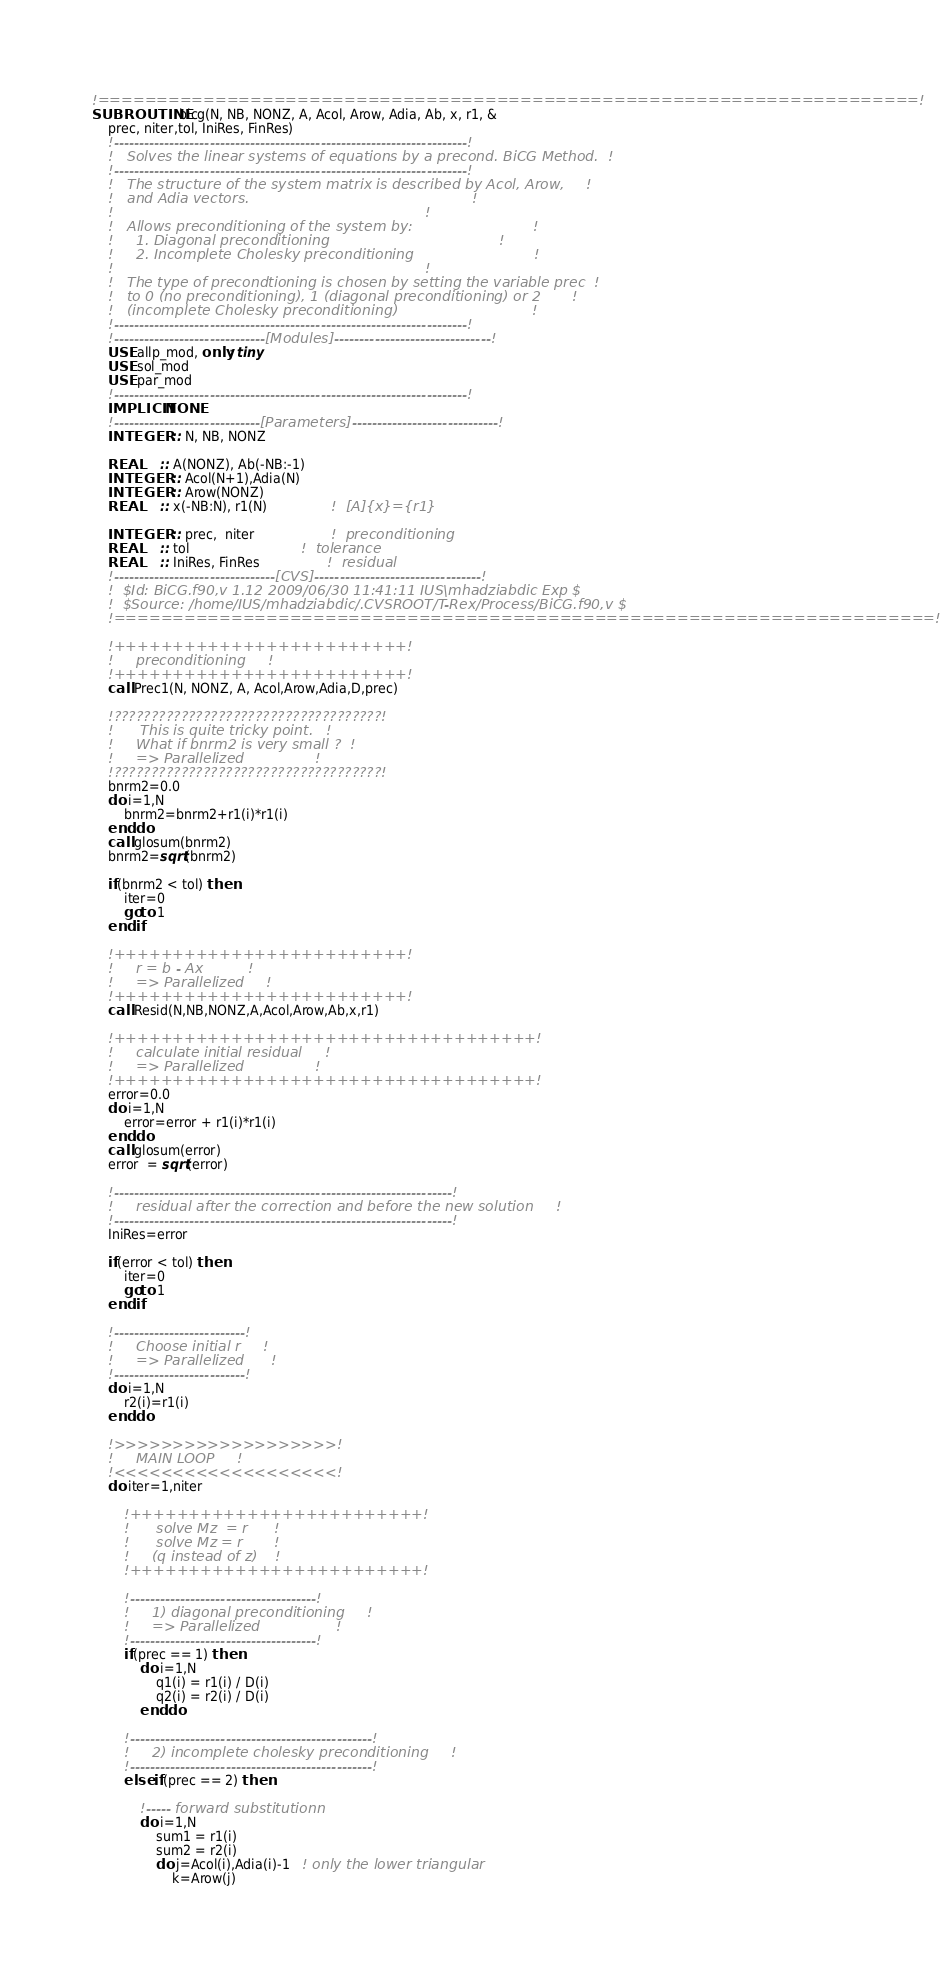Convert code to text. <code><loc_0><loc_0><loc_500><loc_500><_FORTRAN_>!======================================================================!
SUBROUTINE bicg(N, NB, NONZ, A, Acol, Arow, Adia, Ab, x, r1, &
    prec, niter,tol, IniRes, FinRes)
    !----------------------------------------------------------------------!
    !   Solves the linear systems of equations by a precond. BiCG Method.  !
    !----------------------------------------------------------------------!
    !   The structure of the system matrix is described by Acol, Arow,     !
    !   and Adia vectors.                                                  !
    !                                                                      !
    !   Allows preconditioning of the system by:                           !
    !     1. Diagonal preconditioning                                      !
    !     2. Incomplete Cholesky preconditioning                           !
    !                                                                      !
    !   The type of precondtioning is chosen by setting the variable prec  !
    !   to 0 (no preconditioning), 1 (diagonal preconditioning) or 2       !
    !   (incomplete Cholesky preconditioning)                              !
    !----------------------------------------------------------------------!
    !------------------------------[Modules]-------------------------------!
    USE allp_mod, only: tiny
    USE sol_mod
    USE par_mod
    !----------------------------------------------------------------------!
    IMPLICIT NONE
    !-----------------------------[Parameters]-----------------------------!
    INTEGER  :: N, NB, NONZ

    REAL     :: A(NONZ), Ab(-NB:-1)
    INTEGER  :: Acol(N+1),Adia(N)
    INTEGER  :: Arow(NONZ)
    REAL     :: x(-NB:N), r1(N)                !  [A]{x}={r1}

    INTEGER  :: prec,  niter                   !  preconditioning
    REAL     :: tol                            !  tolerance
    REAL     :: IniRes, FinRes                 !  residual
    !--------------------------------[CVS]---------------------------------!
    !  $Id: BiCG.f90,v 1.12 2009/06/30 11:41:11 IUS\mhadziabdic Exp $
    !  $Source: /home/IUS/mhadziabdic/.CVSROOT/T-Rex/Process/BiCG.f90,v $
    !======================================================================!

    !+++++++++++++++++++++++++!
    !     preconditioning     !
    !+++++++++++++++++++++++++!
    call Prec1(N, NONZ, A, Acol,Arow,Adia,D,prec)

    !????????????????????????????????????!
    !      This is quite tricky point.   !
    !     What if bnrm2 is very small ?  !
    !     => Parallelized                !
    !????????????????????????????????????!
    bnrm2=0.0
    do i=1,N
        bnrm2=bnrm2+r1(i)*r1(i)
    end do
    call glosum(bnrm2)
    bnrm2=sqrt(bnrm2)

    if(bnrm2 < tol) then
        iter=0
        goto 1
    end if

    !+++++++++++++++++++++++++!
    !     r = b - Ax          !
    !     => Parallelized     !
    !+++++++++++++++++++++++++!
    call Resid(N,NB,NONZ,A,Acol,Arow,Ab,x,r1)

    !++++++++++++++++++++++++++++++++++++!
    !     calculate initial residual     !
    !     => Parallelized                !
    !++++++++++++++++++++++++++++++++++++!
    error=0.0
    do i=1,N
        error=error + r1(i)*r1(i)
    end do
    call glosum(error)
    error  = sqrt(error)

    !-------------------------------------------------------------------!
    !     residual after the correction and before the new solution     !
    !-------------------------------------------------------------------!
    IniRes=error

    if(error < tol) then
        iter=0
        goto 1
    end if

    !--------------------------!
    !     Choose initial r     !
    !     => Parallelized      !
    !--------------------------!
    do i=1,N
        r2(i)=r1(i)
    end do

    !>>>>>>>>>>>>>>>>>>>!
    !     MAIN LOOP     !
    !<<<<<<<<<<<<<<<<<<<!
    do iter=1,niter

        !+++++++++++++++++++++++++!
        !      solve Mz  = r      !
        !      solve Mz = r       !
        !     (q instead of z)    !
        !+++++++++++++++++++++++++!

        !-------------------------------------!
        !     1) diagonal preconditioning     !
        !     => Parallelized                 !
        !-------------------------------------!
        if(prec == 1) then
            do i=1,N
                q1(i) = r1(i) / D(i)
                q2(i) = r2(i) / D(i)
            end do

        !------------------------------------------------!
        !     2) incomplete cholesky preconditioning     !
        !------------------------------------------------!
        else if(prec == 2) then

            !----- forward substitutionn
            do i=1,N
                sum1 = r1(i)
                sum2 = r2(i)
                do j=Acol(i),Adia(i)-1   ! only the lower triangular
                    k=Arow(j)</code> 